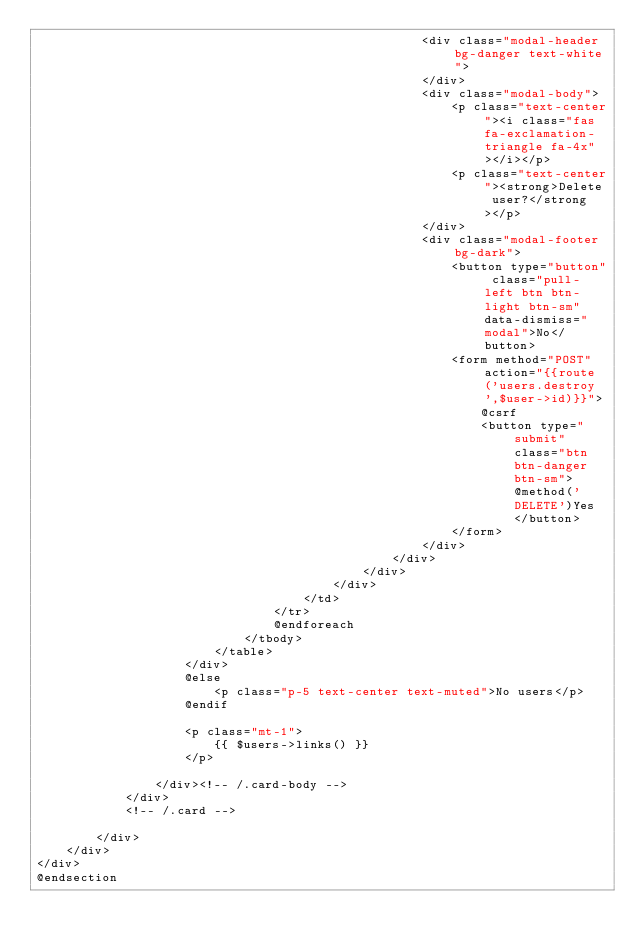<code> <loc_0><loc_0><loc_500><loc_500><_PHP_>                                                    <div class="modal-header bg-danger text-white">
                                                    </div>
                                                    <div class="modal-body">
                                                        <p class="text-center"><i class="fas fa-exclamation-triangle fa-4x"></i></p>
                                                        <p class="text-center"><strong>Delete user?</strong></p>
                                                    </div>
                                                    <div class="modal-footer bg-dark">
                                                        <button type="button" class="pull-left btn btn-light btn-sm" data-dismiss="modal">No</button>
                                                        <form method="POST" action="{{route('users.destroy',$user->id)}}">
                                                            @csrf
                                                            <button type="submit" class="btn btn-danger btn-sm"> @method('DELETE')Yes</button>
                                                        </form>
                                                    </div>
                                                </div>
                                            </div>
                                        </div>
                                    </td>
                                </tr>
                                @endforeach
                            </tbody>
                        </table>
                    </div>
                    @else
                        <p class="p-5 text-center text-muted">No users</p>
                    @endif

                    <p class="mt-1">
                        {{ $users->links() }}
                    </p>

                </div><!-- /.card-body -->
            </div>
            <!-- /.card -->

        </div>
    </div>
</div>
@endsection
</code> 